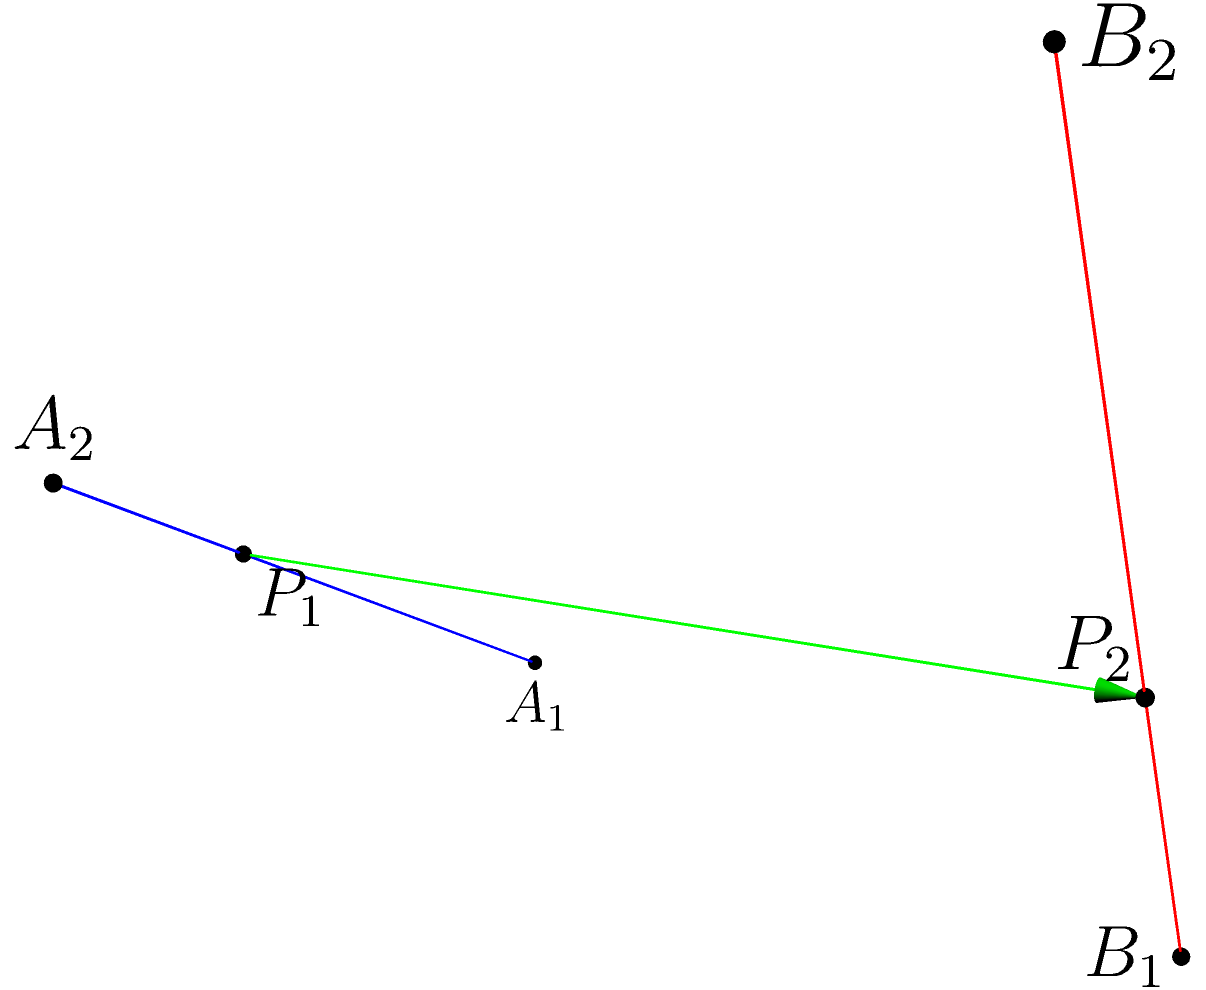Imagine you're trying to set up two GoPro cameras for a unique action shot. The first camera is mounted on a line from point $A_1(0,0,0)$ to $A_2(2,0,1)$, while the second camera is on a line from $B_1(1,2,0)$ to $B_2(2,2,2)$. To ensure the best shot, you need to find the shortest distance between these two camera lines. What is this shortest distance? To find the shortest distance between two skew lines in 3D space, we'll follow these steps:

1) First, we need to represent our lines parametrically:
   Line 1: $\mathbf{r_1}(t) = A_1 + t\mathbf{v_1}$ where $\mathbf{v_1} = A_2 - A_1 = (2,0,1)$
   Line 2: $\mathbf{r_2}(s) = B_1 + s\mathbf{v_2}$ where $\mathbf{v_2} = B_2 - B_1 = (1,0,2)$

2) The vector perpendicular to both lines is $\mathbf{n} = \mathbf{v_1} \times \mathbf{v_2}$:
   $\mathbf{n} = (0,1,0) \times (1,0,2) = (2,-1,0)$

3) Let $\mathbf{w_0} = B_1 - A_1 = (1,2,0)$

4) Now, we can find the parameters $t$ and $s$ for the points of closest approach:
   $t = \frac{(\mathbf{w_0} \times \mathbf{v_2}) \cdot \mathbf{n}}{\mathbf{n} \cdot \mathbf{n}}$
   $s = \frac{(\mathbf{w_0} \times \mathbf{v_1}) \cdot \mathbf{n}}{\mathbf{n} \cdot \mathbf{n}}$

5) Calculating:
   $t = \frac{((1,2,0) \times (1,0,2)) \cdot (2,-1,0)}{(2,-1,0) \cdot (2,-1,0)} = \frac{(-4,1,2) \cdot (2,-1,0)}{5} = \frac{-9}{5}$
   $s = \frac{((1,2,0) \times (2,0,1)) \cdot (2,-1,0)}{(2,-1,0) \cdot (2,-1,0)} = \frac{(-2,1,4) \cdot (2,-1,0)}{5} = \frac{-3}{5}$

6) The points of closest approach are:
   $P_1 = A_1 + t\mathbf{v_1} = (0,0,0) + \frac{-9}{5}(2,0,1) = (\frac{-18}{5},0,\frac{-9}{5})$
   $P_2 = B_1 + s\mathbf{v_2} = (1,2,0) + \frac{-3}{5}(1,0,2) = (\frac{2}{5},2,\frac{-6}{5})$

7) The shortest distance is the magnitude of the vector between these points:
   $\mathbf{d} = P_2 - P_1 = (\frac{20}{5},2,\frac{3}{5})$
   Distance = $\|\mathbf{d}\| = \sqrt{(\frac{20}{5})^2 + 2^2 + (\frac{3}{5})^2} = \sqrt{\frac{409}{25}} = \frac{\sqrt{409}}{5}$
Answer: $\frac{\sqrt{409}}{5}$ units 